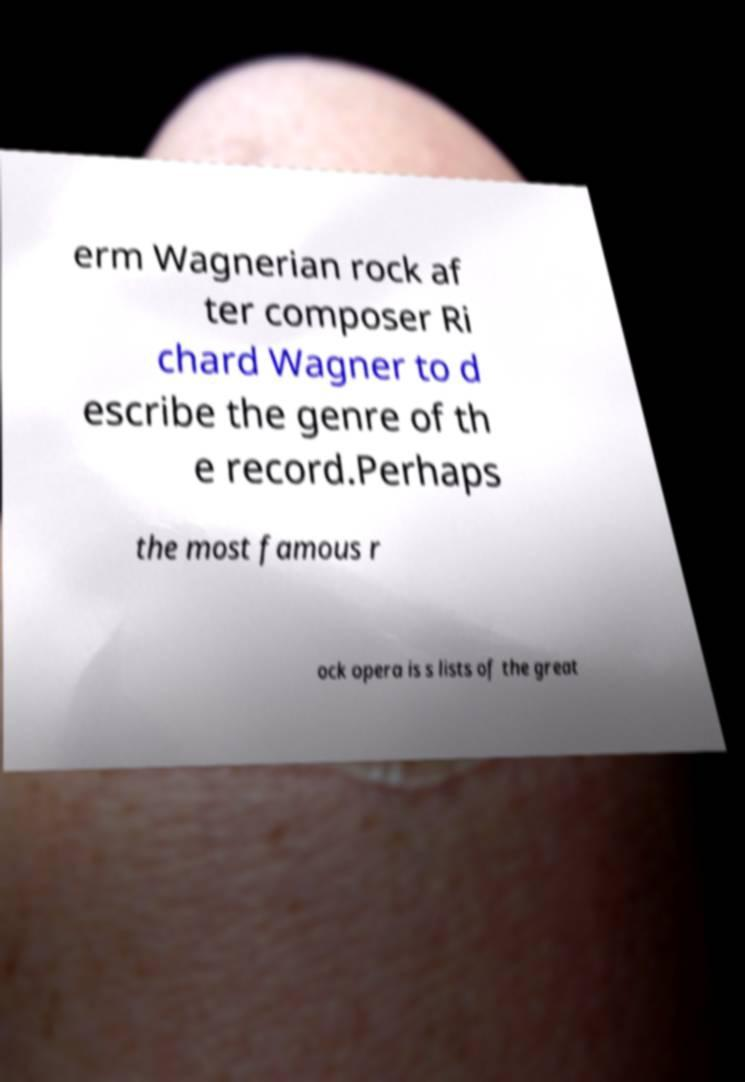Could you extract and type out the text from this image? erm Wagnerian rock af ter composer Ri chard Wagner to d escribe the genre of th e record.Perhaps the most famous r ock opera is s lists of the great 